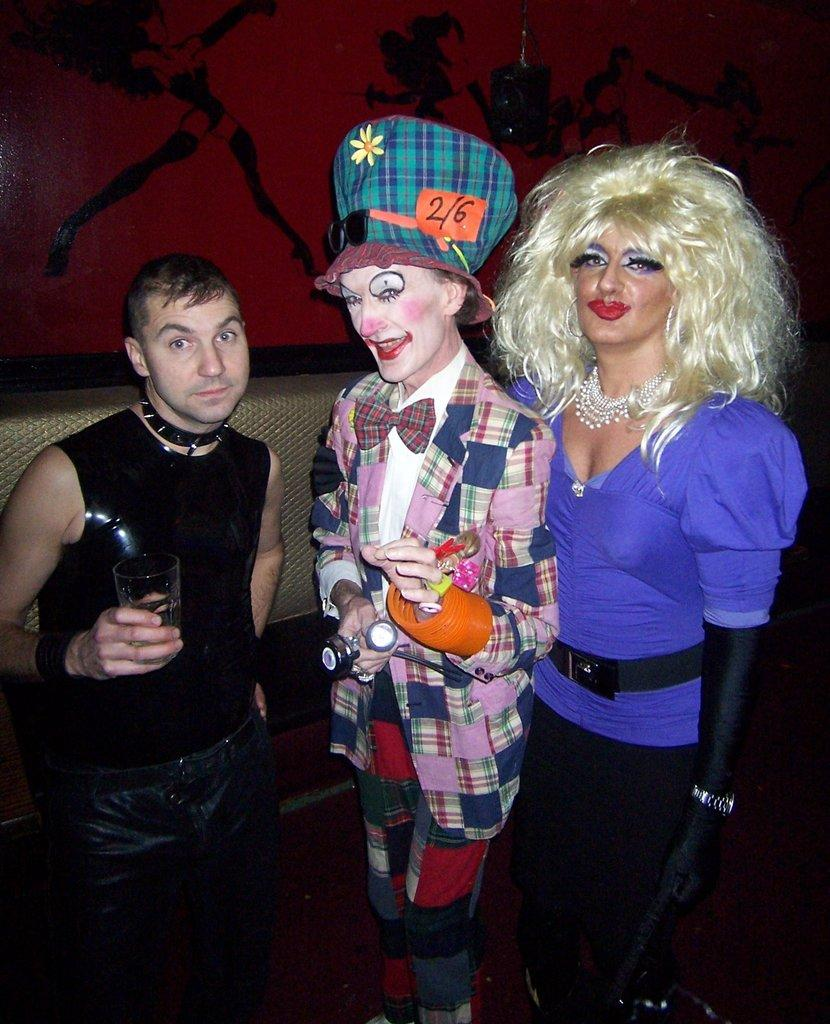What can be seen in the image? There are people standing in the image. What are the people holding in their hands? The people are holding something in their hands. What is visible on the wall in the image? There is a wall visible in the image, and there is a painting on the wall. What is the value of the debt owed by the people in the image? There is no mention of debt in the image, so it is not possible to determine its value. 